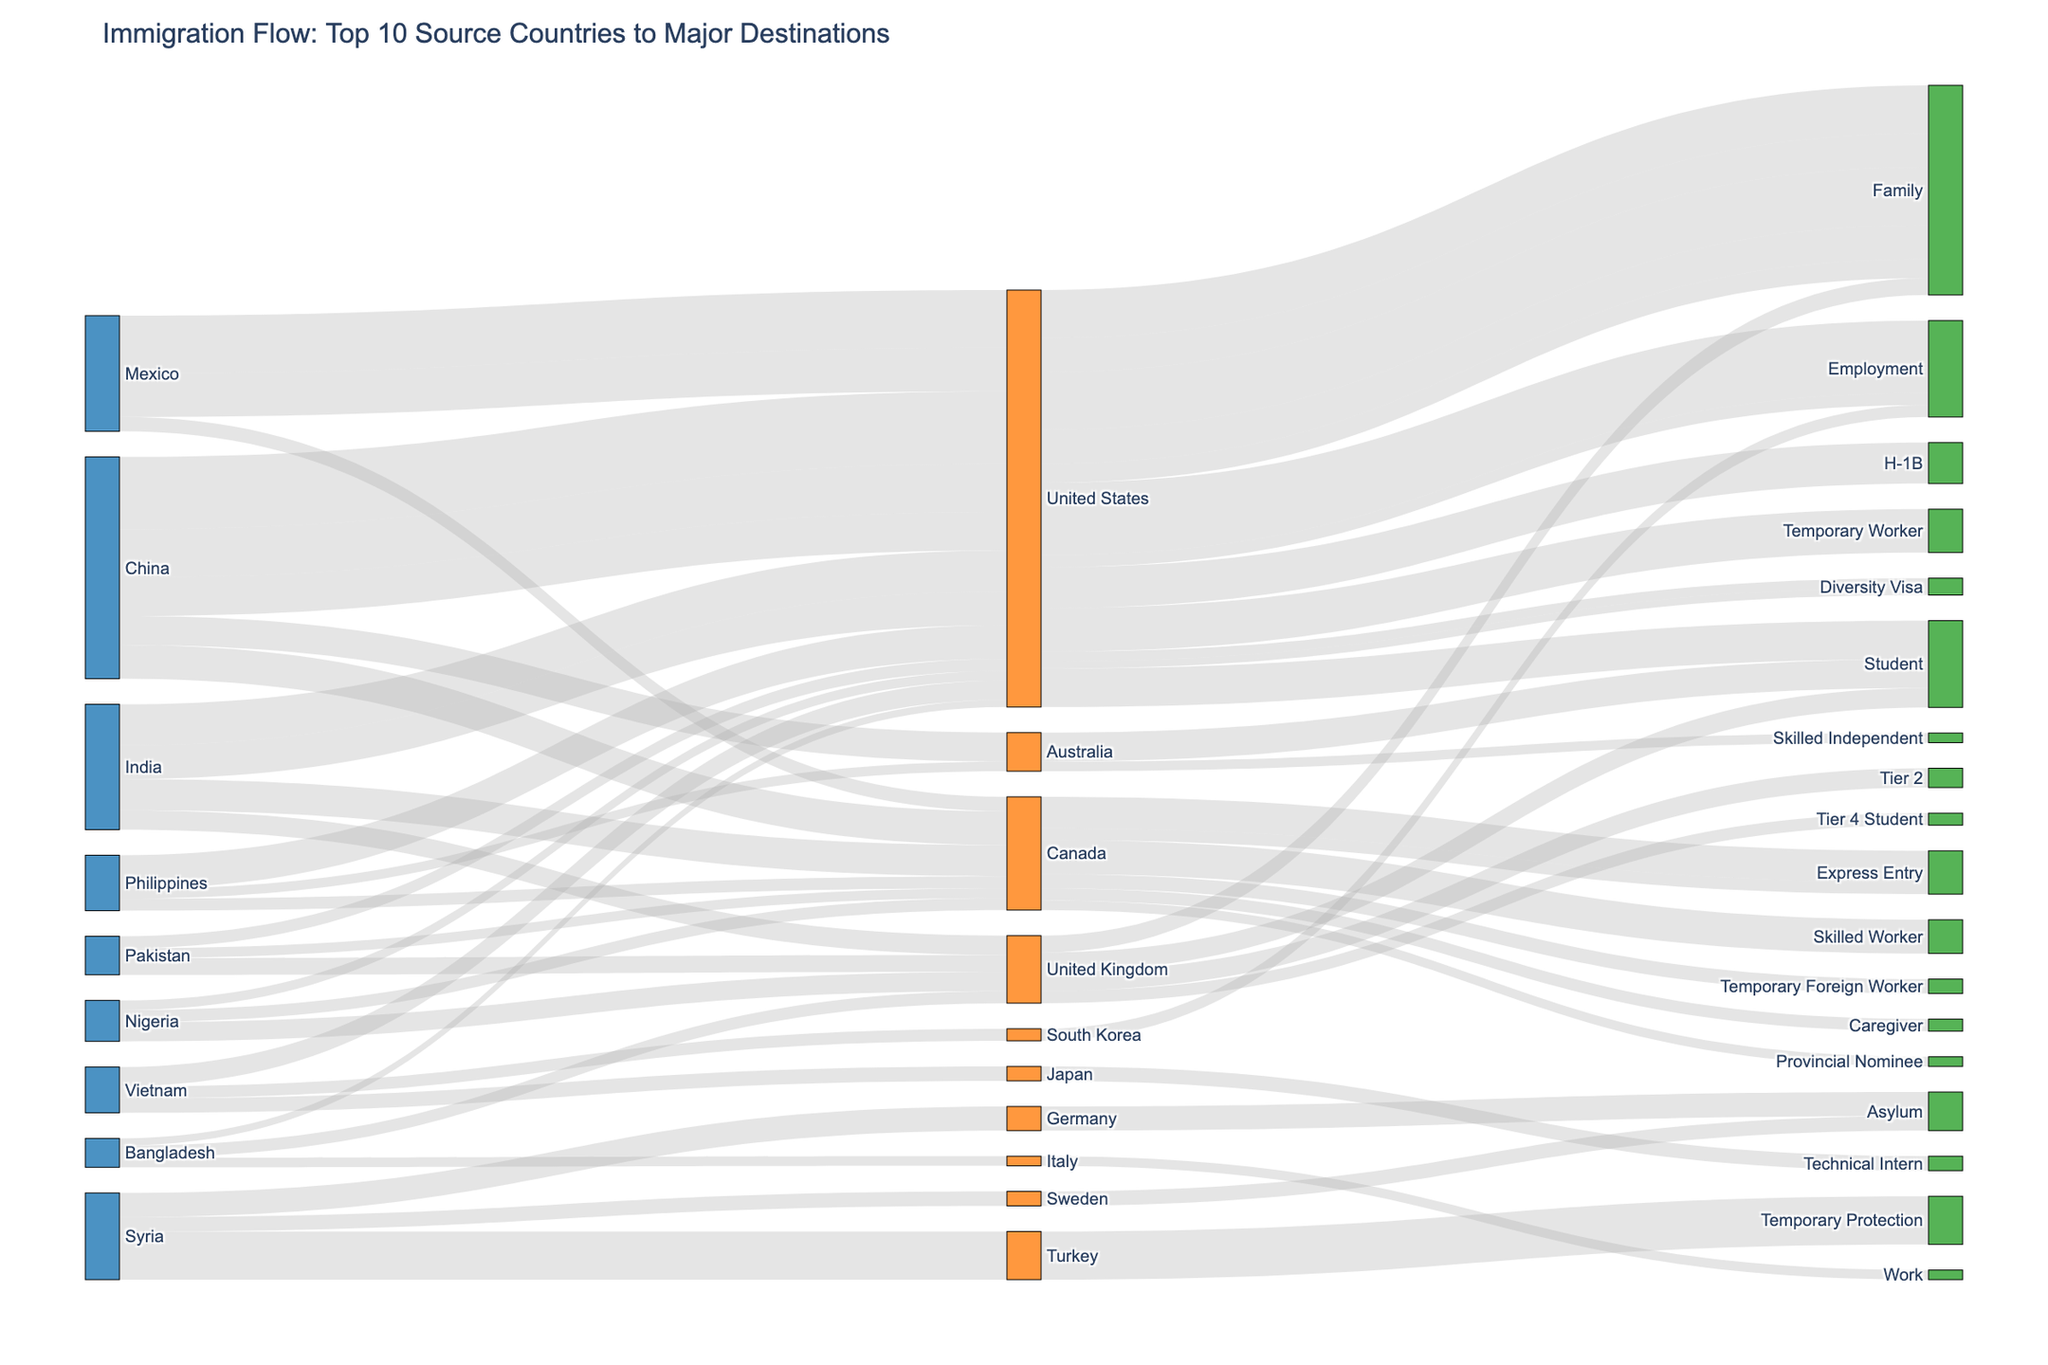what is the title of the figure? The title is usually found at the top of the figure, indicating the main topic or focus. In this case, it's stated in the code as "Immigration Flow: Top 10 Source Countries to Major Destinations".
Answer: Immigration Flow: Top 10 Source Countries to Major Destinations How many source countries are represented in the diagram? The code identifies unique source countries and assigns them indices. The length of the source_indices dictionary gives the total number of unique source countries.
Answer: 10 Which visa type has the highest number of immigrants from China to the United States? To determine this, look at the links from China to the United States and then to the Visa Types. The values are given in the dataset: 150,000 for Employment, 100,000 for Family, and 80,000 for Student. Employment has the highest value.
Answer: Employment Which destination country receives the most immigrants from Syria? Check the links originating from Syria to various destination countries. The dataset provides the values: 50,000 to Germany, 30,000 to Sweden, and 100,000 to Turkey. Turkey has the highest value.
Answer: Turkey What is the total number of immigrants from India going to all destination countries? Sum the values of all the links that originate from India: 85,000 (US - H-1B) + 70,000 (US - Family) + 65,000 (Canada - Express Entry) + 40,000 (UK - Tier 2). This simplifies to 85K + 70K + 65K + 40K = 260K.
Answer: 260,000 Compare the immigration flow to Canada from China and Mexico. Which source country sends more immigrants and by how much? From the dataset, the values are: China to Canada - 70,000 (Skilled Worker), Mexico to Canada - 30,000 (Temporary Foreign Worker). The difference is 70,000 - 30,000.
Answer: China sends 40,000 more immigrants How many immigrants use the Diversity Visa in this dataset? Find the values in the dataset where the Visa Type is Diversity Visa and sum them: Bangladesh to the US (15,000) and Nigeria to the US (20,000). This equals 15,000 + 20,000.
Answer: 35,000 What is the most common visa type for immigrants from the Philippines to any destination? Check the visa types associated with the Philippines in the dataset: Family (70,000 to the US), Caregiver (25,000 to Canada), and Skilled Independent (20,000 to Australia). Family is the most common.
Answer: Family Which destination country receives the most students from Nigeria? The link from Nigeria to the destination country for students is: 40,000 to the UK. This is the only student link, therefore the UK is the answer.
Answer: United Kingdom Compare the total number of family visa immigrants arriving in the US versus those arriving in the UK. Sum the values for the Family visa type for each country: US (China: 100,000 + India: 70,000 + Mexico: 120,000 + Philippines: 70,000 + Vietnam: 40,000 = 400,000) and UK (Pakistan: 35,000). Compare 400,000 and 35,000.
Answer: US receives 365,000 more Family visa immigrants than the UK 